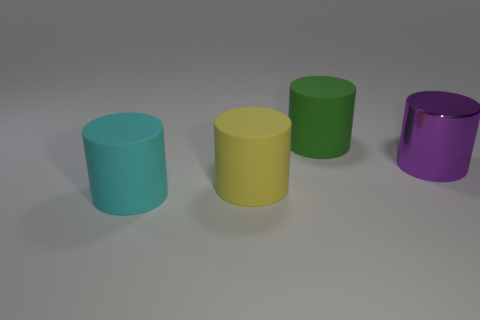What is the color of the thing that is behind the large purple shiny object?
Offer a terse response. Green. What number of other objects are the same size as the yellow cylinder?
Your response must be concise. 3. There is a rubber object that is both on the right side of the cyan rubber cylinder and to the left of the green matte cylinder; what size is it?
Give a very brief answer. Large. Are there any yellow matte objects of the same shape as the purple thing?
Give a very brief answer. Yes. What number of objects are either brown cylinders or matte cylinders in front of the purple shiny cylinder?
Provide a succinct answer. 2. How many other things are the same material as the purple object?
Your response must be concise. 0. What number of objects are either big yellow metallic things or big metal cylinders?
Offer a very short reply. 1. Are there more large yellow rubber cylinders that are to the left of the large green rubber cylinder than green matte objects in front of the big shiny cylinder?
Your response must be concise. Yes. There is another large shiny object that is the same shape as the large cyan thing; what is its color?
Keep it short and to the point. Purple. Is the number of large things in front of the big yellow object greater than the number of yellow matte cubes?
Ensure brevity in your answer.  Yes. 